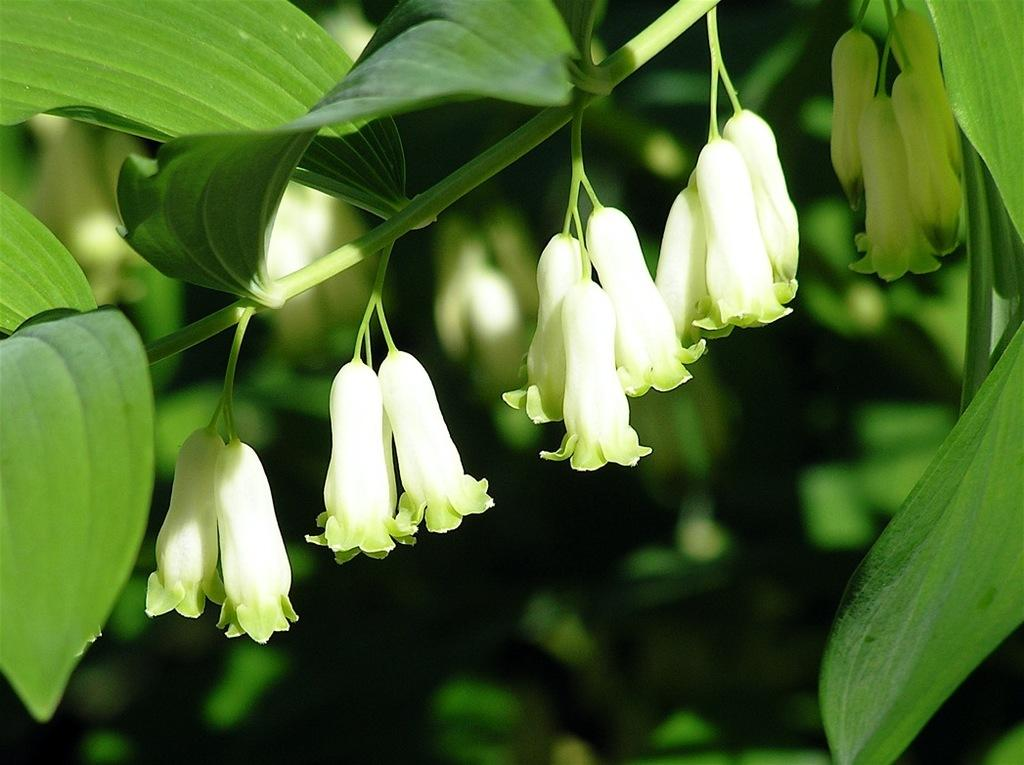What type of plant parts can be seen in the image? There are flowers, leaves, and stems in the image. Who is the writer of the credit card seen in the image? There is no credit card or writer mentioned in the image; it only features flowers, leaves, and stems. 